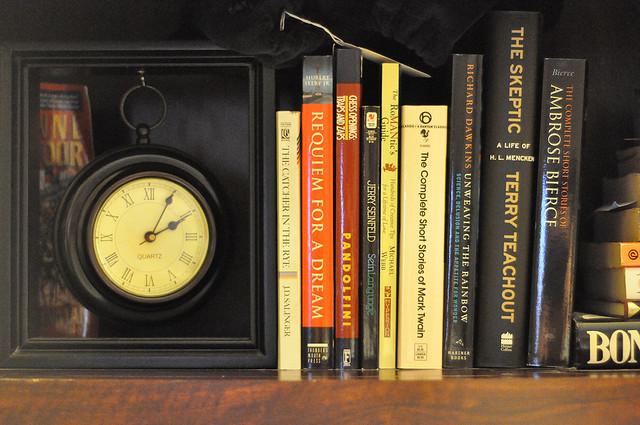Which book is authored by Terry Teachout?
Quick response, please. The skeptic. What type of clock is it?
Quick response, please. Analog. What is the time on the clock?
Give a very brief answer. 2:05. 